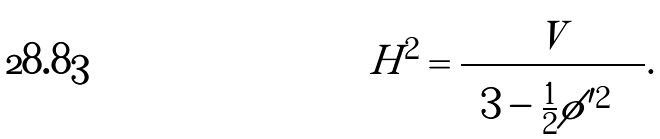Convert formula to latex. <formula><loc_0><loc_0><loc_500><loc_500>H ^ { 2 } & = \frac { V } { \left ( 3 - \frac { 1 } { 2 } | \phi ^ { \prime } | ^ { 2 } \right ) } .</formula> 